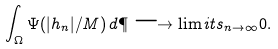Convert formula to latex. <formula><loc_0><loc_0><loc_500><loc_500>\int _ { \Omega } \Psi ( | h _ { n } | / M ) \, d \P \longrightarrow \lim i t s _ { n \to \infty } 0 .</formula> 